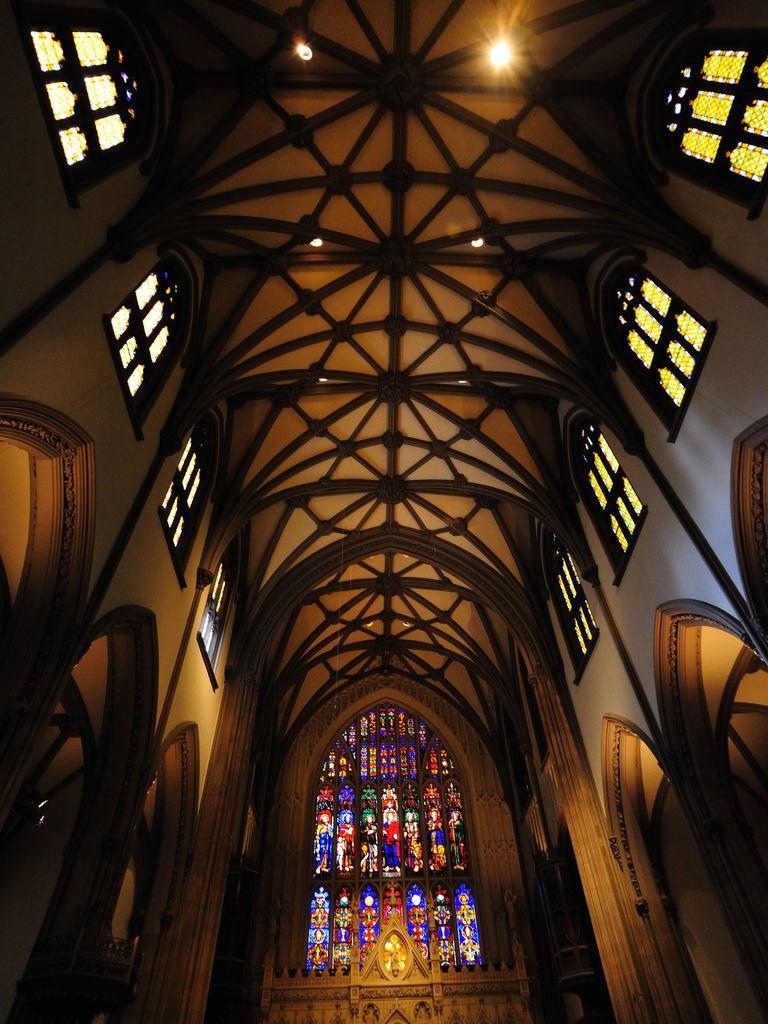Could you give a brief overview of what you see in this image? This is inside view of a building. We can see windows, walls, lights on the ceiling, designs on the glasses and other objects. 